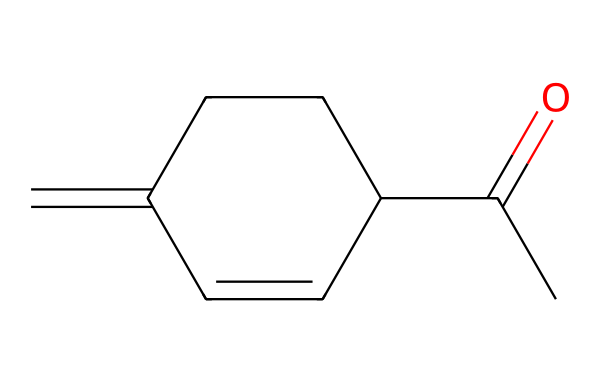What is the molecular formula of jasmone? To determine the molecular formula from the SMILES representation, we identify the types and counts of atoms. The given SMILES corresponds to a molecule with 10 carbon atoms, 12 hydrogen atoms, and 1 oxygen atom. Therefore, the molecular formula is C10H12O.
Answer: C10H12O How many double bonds are present in this molecule? By analyzing the structure derived from the SMILES, we see that there are three double bonds: one in the carbonyl group (C=O) and two within the ring system. Thus, there are three double bonds in total.
Answer: three What functional group characterizes jasmone? The presence of the carbonyl group (C=O) is indicative of the ketone functional group. This functional group is a defining characteristic of jasmone's structure.
Answer: ketone What is the main type of chemical bond found in jasmone? The prevalent types of bonds in jasmone are covalent bonds, which include single bonds and double bonds connecting carbon, hydrogen, and oxygen atoms.
Answer: covalent How many rings are present in the structure of jasmone? The structure contains one cyclohexene ring, which is evident when interpreting the SMILES notation. There are no additional rings present.
Answer: one What type of scent is associated with jasmone? Jasmone is associated with a floral scent, particularly reminiscent of jasmine flowers. This is due to the specific arrangement of its atoms and functional groups which contribute to its aromatic qualities.
Answer: floral 